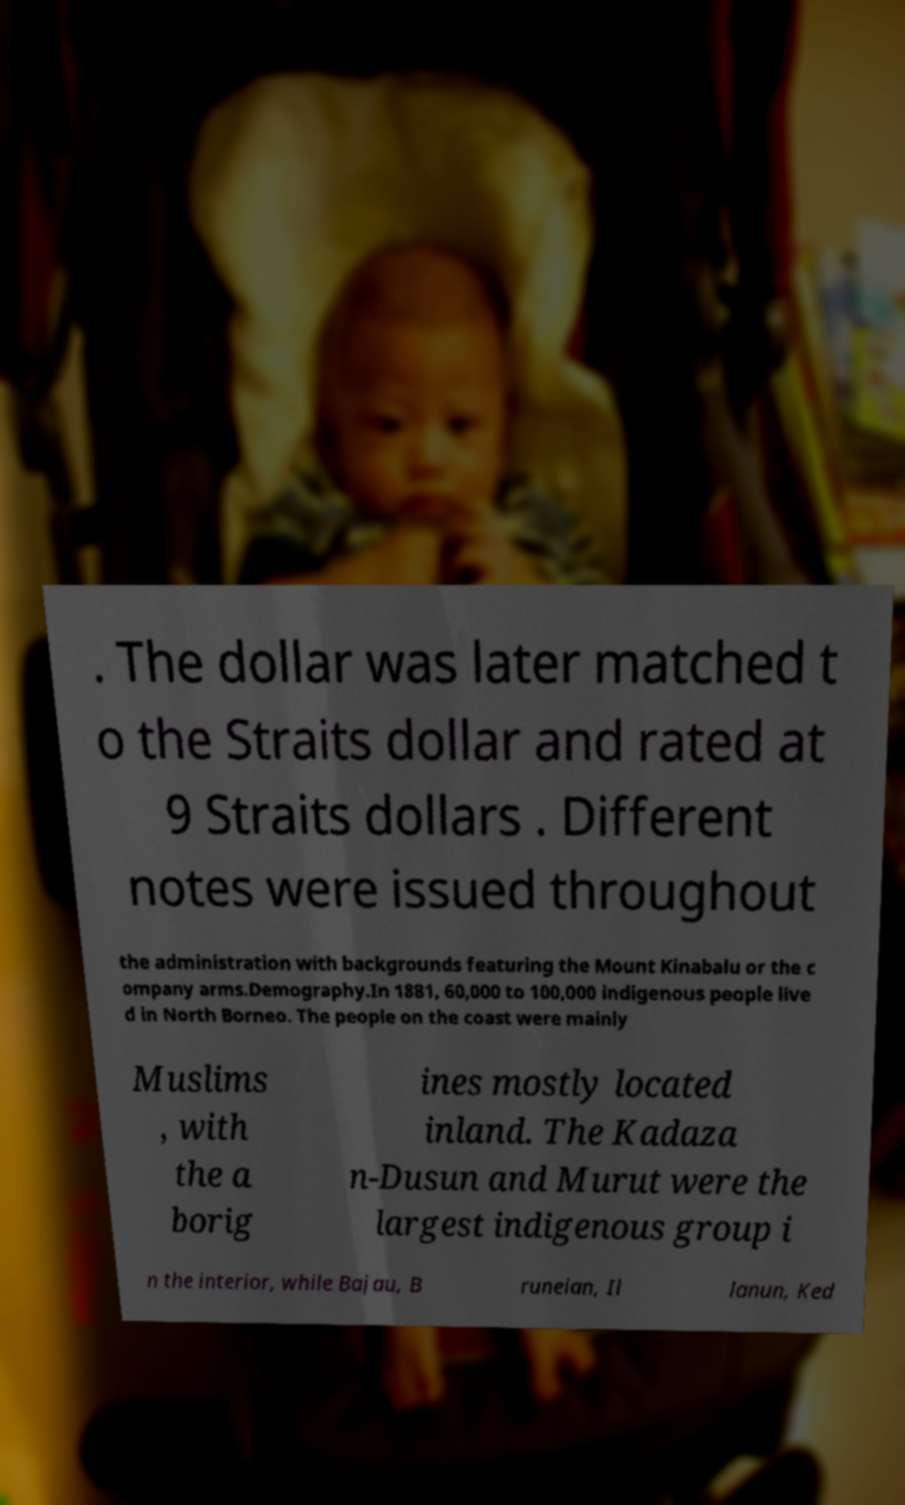Could you extract and type out the text from this image? . The dollar was later matched t o the Straits dollar and rated at 9 Straits dollars . Different notes were issued throughout the administration with backgrounds featuring the Mount Kinabalu or the c ompany arms.Demography.In 1881, 60,000 to 100,000 indigenous people live d in North Borneo. The people on the coast were mainly Muslims , with the a borig ines mostly located inland. The Kadaza n-Dusun and Murut were the largest indigenous group i n the interior, while Bajau, B runeian, Il lanun, Ked 